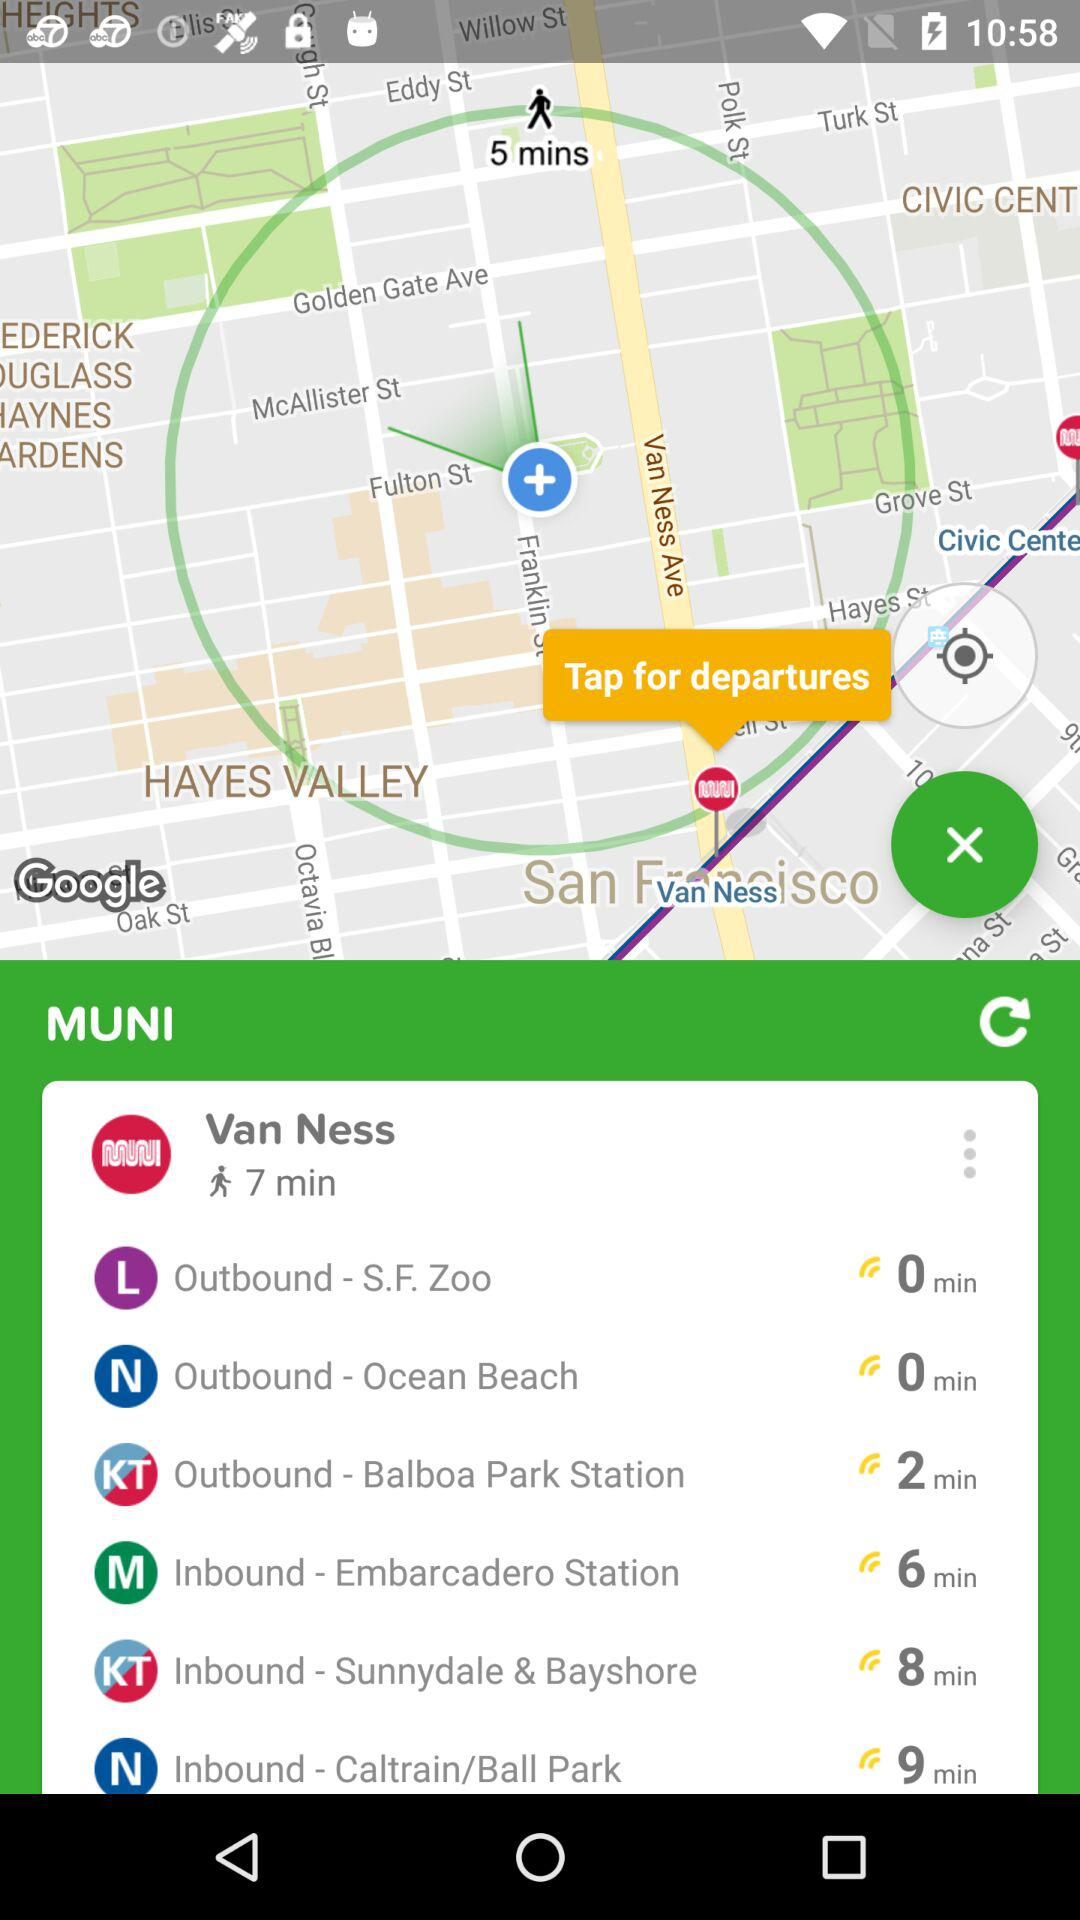Which has the highest min of distance by walking?
When the provided information is insufficient, respond with <no answer>. <no answer> 